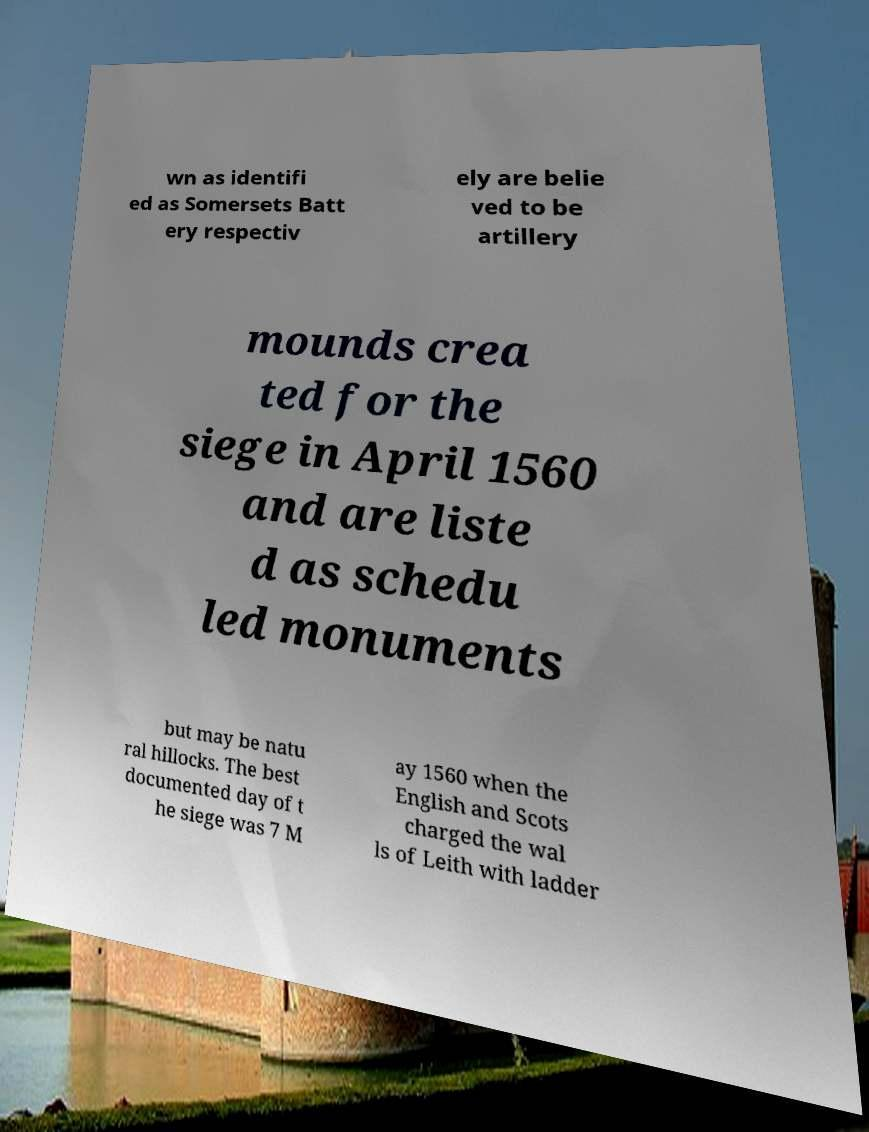Can you read and provide the text displayed in the image?This photo seems to have some interesting text. Can you extract and type it out for me? wn as identifi ed as Somersets Batt ery respectiv ely are belie ved to be artillery mounds crea ted for the siege in April 1560 and are liste d as schedu led monuments but may be natu ral hillocks. The best documented day of t he siege was 7 M ay 1560 when the English and Scots charged the wal ls of Leith with ladder 